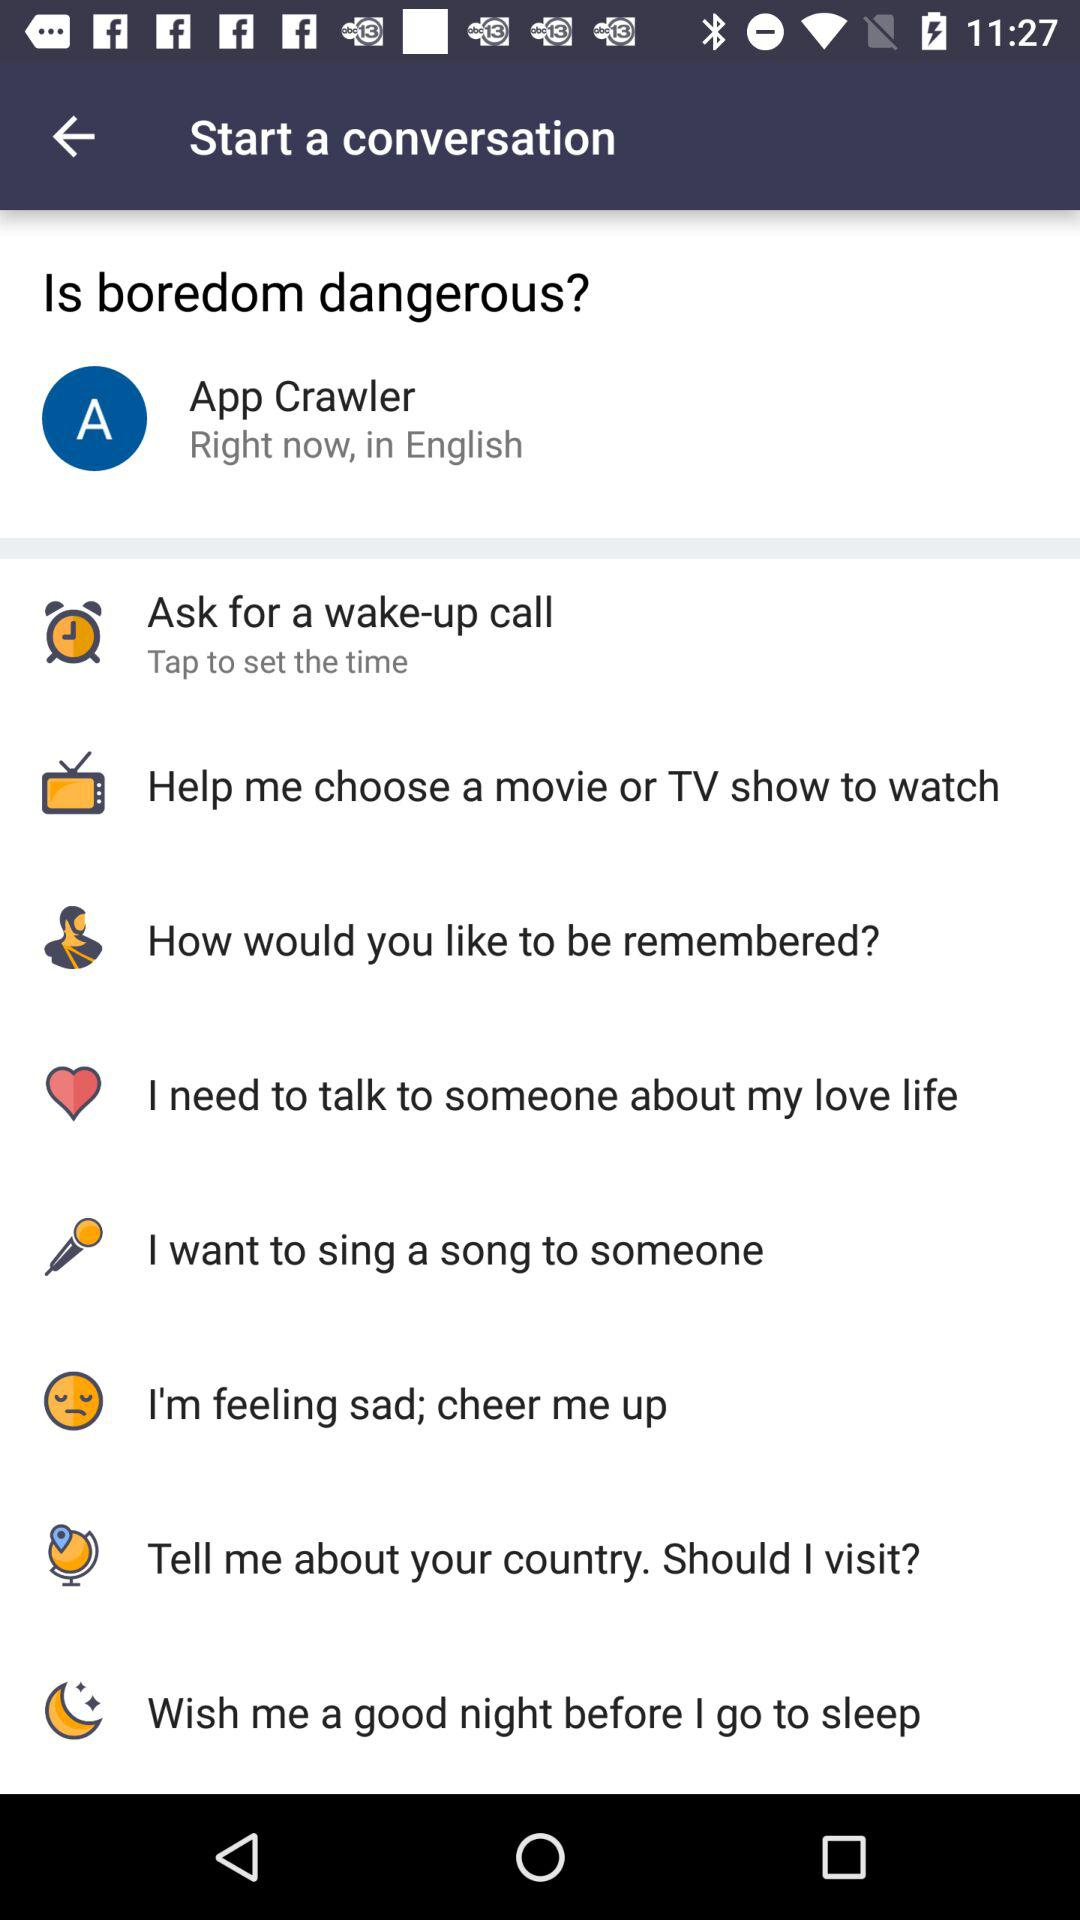How to set the wake-up call?
When the provided information is insufficient, respond with <no answer>. <no answer> 